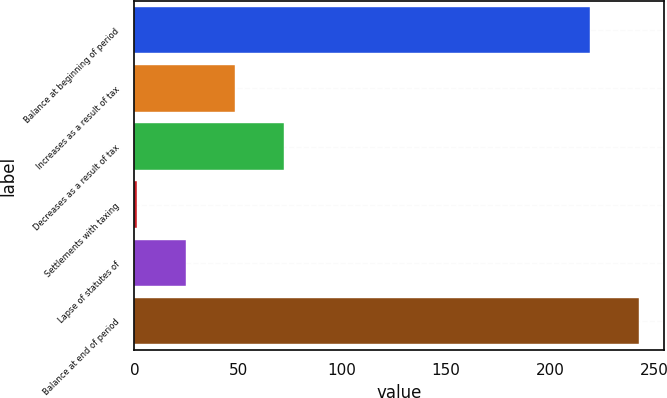<chart> <loc_0><loc_0><loc_500><loc_500><bar_chart><fcel>Balance at beginning of period<fcel>Increases as a result of tax<fcel>Decreases as a result of tax<fcel>Settlements with taxing<fcel>Lapse of statutes of<fcel>Balance at end of period<nl><fcel>219.2<fcel>48.48<fcel>72.17<fcel>1.1<fcel>24.79<fcel>242.89<nl></chart> 